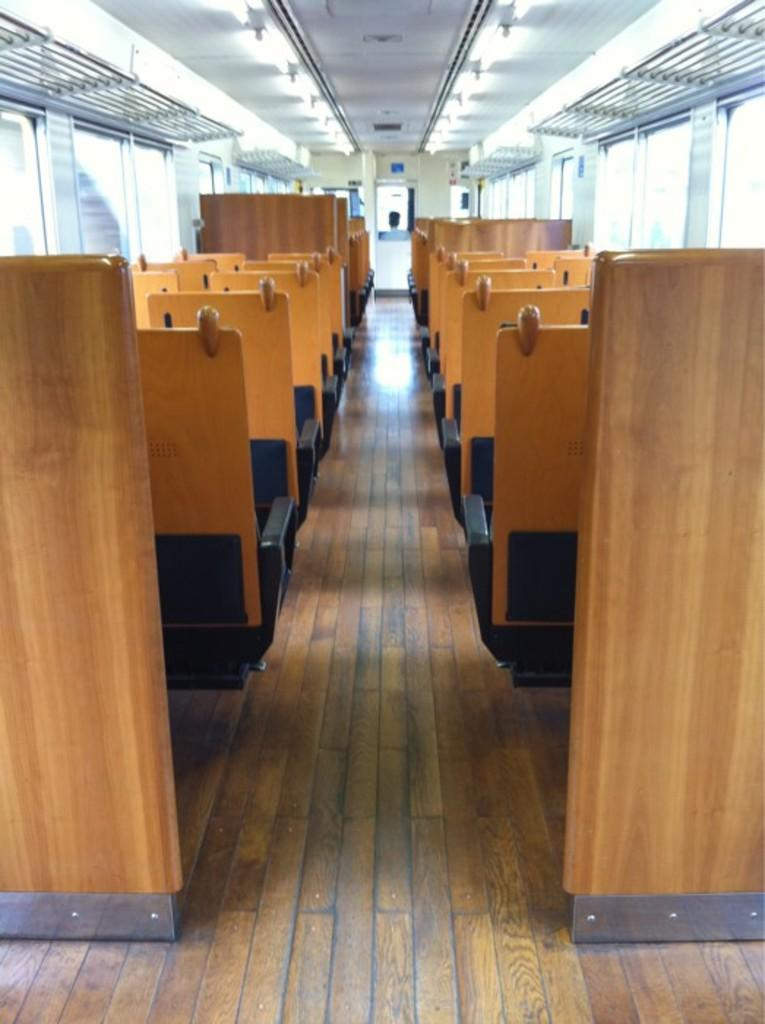What type of structures are present in the image? There are cabins in the image. What is the color of the boards that can be seen in the image? The boards in the image are brown in color. Can you see a crow perched on the roof of one of the cabins in the image? There is no crow visible on the roof of any cabin in the image. Is there a spark emanating from the boards in the image? There is no spark present in the image; it only features cabins and brown color boards. 